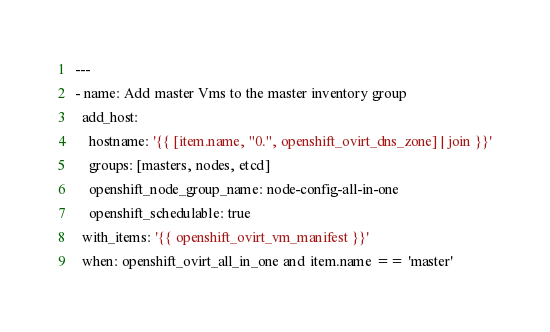Convert code to text. <code><loc_0><loc_0><loc_500><loc_500><_YAML_>---
- name: Add master Vms to the master inventory group
  add_host:
    hostname: '{{ [item.name, "0.", openshift_ovirt_dns_zone] | join }}'
    groups: [masters, nodes, etcd]
    openshift_node_group_name: node-config-all-in-one
    openshift_schedulable: true
  with_items: '{{ openshift_ovirt_vm_manifest }}'
  when: openshift_ovirt_all_in_one and item.name == 'master'
</code> 